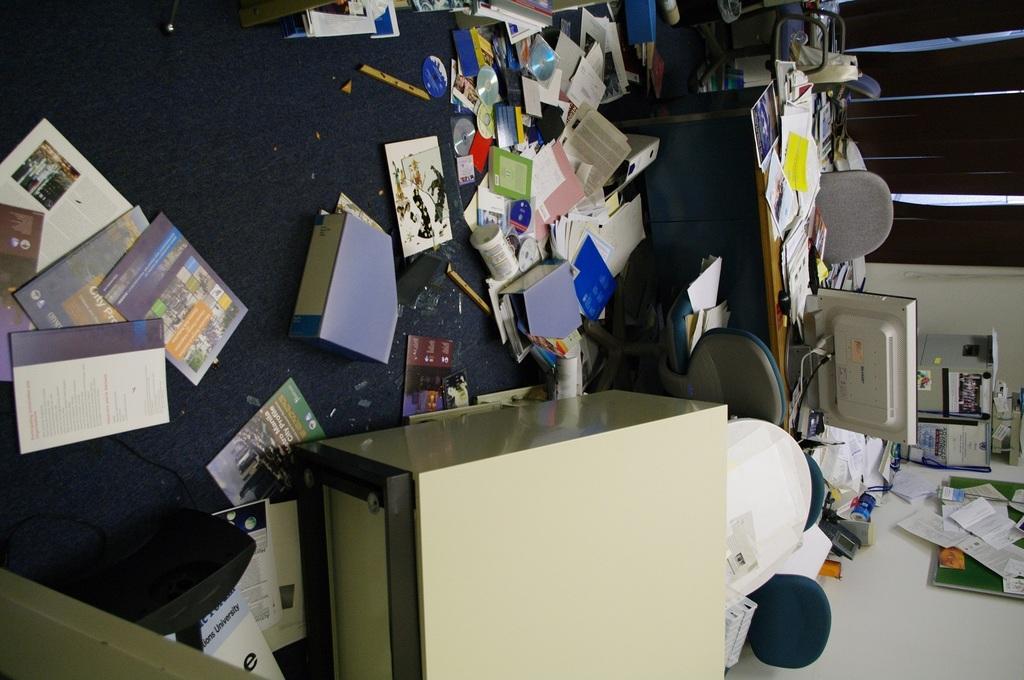Could you give a brief overview of what you see in this image? The picture is an inverted image. On the floor there are many books, cups, CDs. On the table there are books, monitor. There are few chairs over here. On the cars there are books. On the wall there is a board. On the board there are papers. In the background there is a window. 